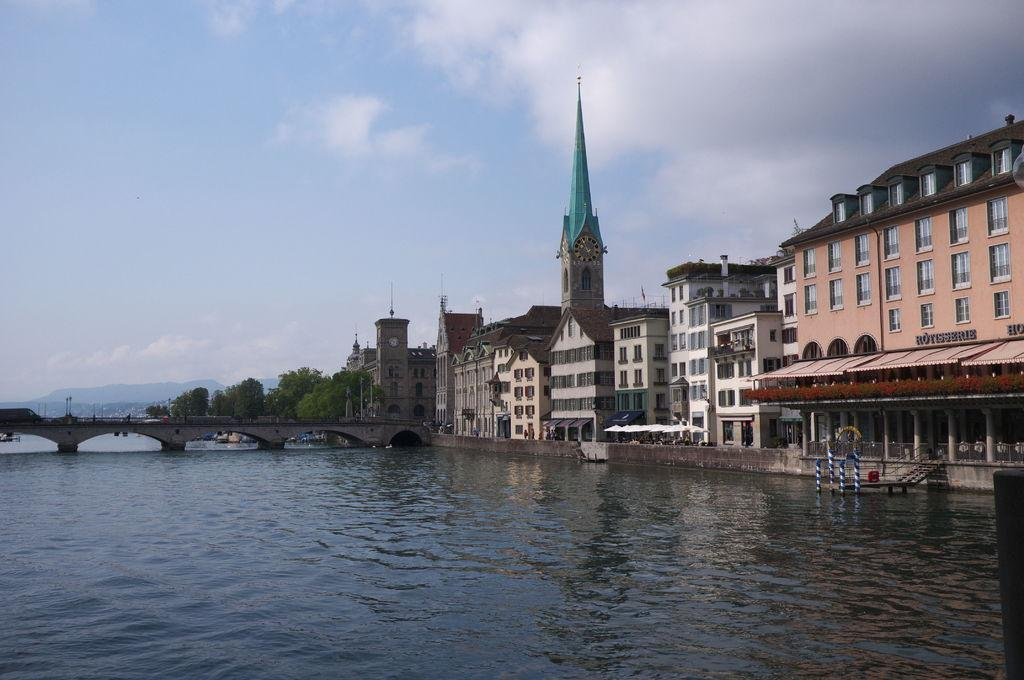What is in the foreground of the image? There is water in the foreground of the image. What can be seen on the right side of the image? There are buildings on the right side of the image. What is visible in the center of the background? In the center of the background, there are trees, buildings, a bridge, and a hill. How would you describe the sky in the image? The sky is slightly cloudy. What type of celery is being served as a side dish in the image? There is no celery or meal present in the image; it features a landscape with water, buildings, trees, a bridge, and a hill. 